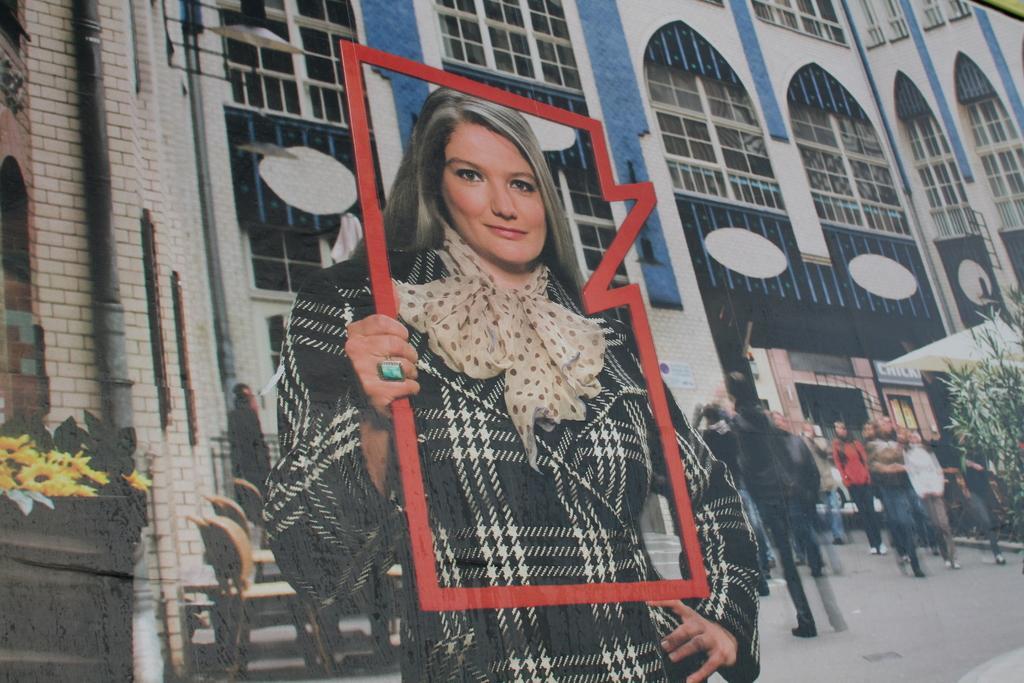Could you give a brief overview of what you see in this image? In this picture I can see an image, where I can see a woman standing in front and holding a red color thing. In the background I can see number of people standing on the path and I can see few plants. I can also see a building. 